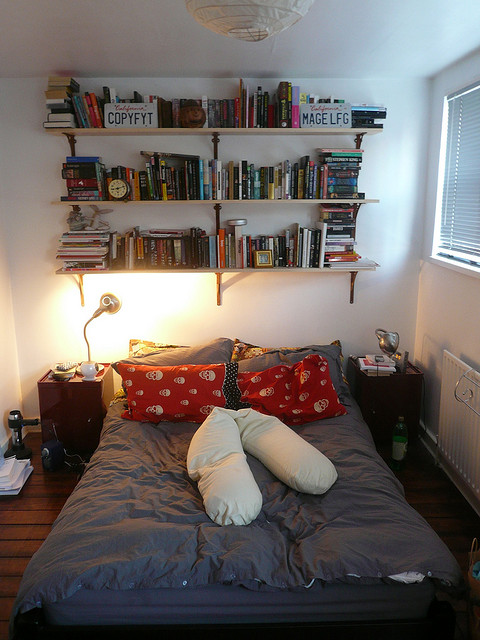Create a vibrant, imaginative story about how the books on the shelf came to be there. Once upon a time, there was a young adventurer named Alex, who journeyed through mystical lands and realms in search of knowledge. Each book on the shelf represents a tale collected from a different dimension. 'Copyfyt' was found in a magical library hidden deep within the enchanted forest of Eldoria, guarded by talking trees and ancient spirits. 'Mage LFG' was a gift from a legendary sorcerer Alex assisted in a clash against dark forces. Other volumes came from sky kingdoms, underwater cities, and even from the future, where Alex befriended time travelers. This eclectic collection is not just a library but a testament to a lifetime of unparalleled adventures. 